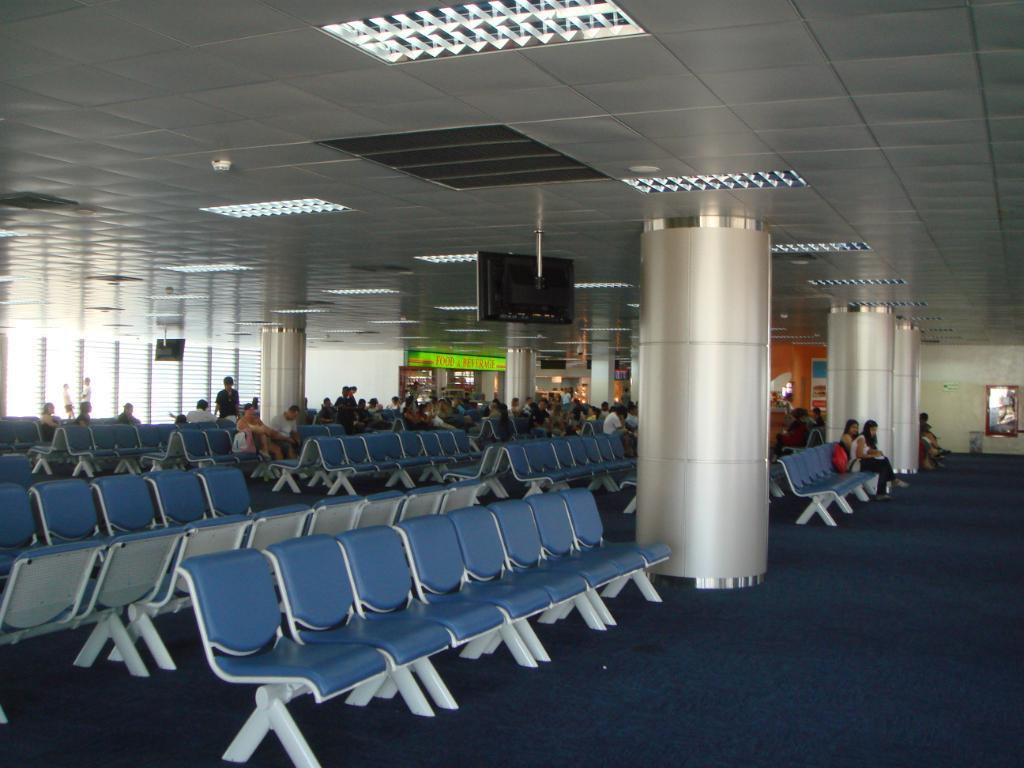Can you describe this image briefly? In this picture I can observe few people sitting on the chairs. In this picture I can observe blue color chairs. I can observe a television fixed to the ceiling in the middle of the picture. On the right side I can observe wall. 